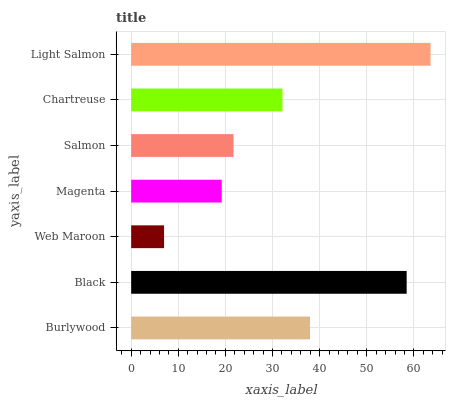Is Web Maroon the minimum?
Answer yes or no. Yes. Is Light Salmon the maximum?
Answer yes or no. Yes. Is Black the minimum?
Answer yes or no. No. Is Black the maximum?
Answer yes or no. No. Is Black greater than Burlywood?
Answer yes or no. Yes. Is Burlywood less than Black?
Answer yes or no. Yes. Is Burlywood greater than Black?
Answer yes or no. No. Is Black less than Burlywood?
Answer yes or no. No. Is Chartreuse the high median?
Answer yes or no. Yes. Is Chartreuse the low median?
Answer yes or no. Yes. Is Burlywood the high median?
Answer yes or no. No. Is Burlywood the low median?
Answer yes or no. No. 